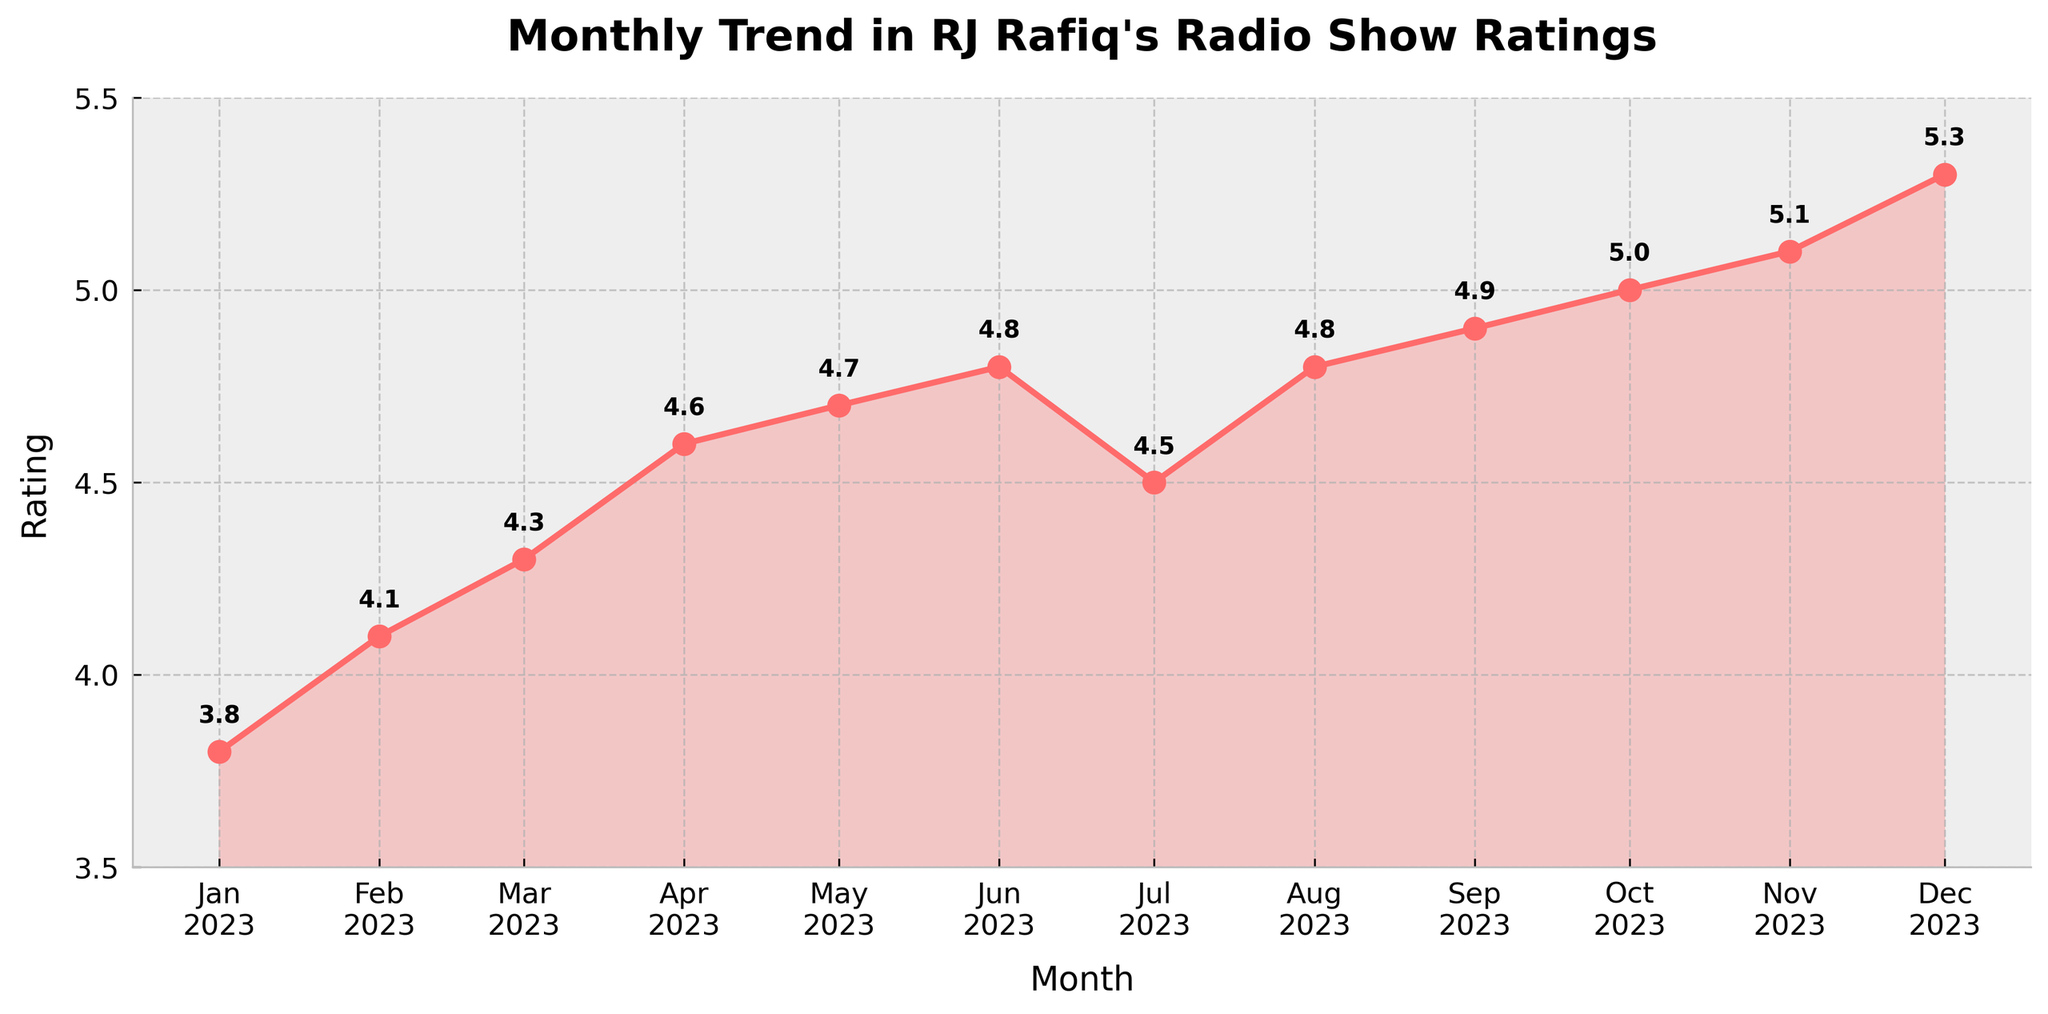What's the range of the ratings throughout the year? The range is calculated by subtracting the minimum rating from the maximum rating observed in the plot. The lowest rating is 3.8 (January) and the highest is 5.3 (December). Thus, the range is 5.3 - 3.8.
Answer: 1.5 Which months have the highest rating? From the plot, the highest rating observed is 5.3. This occurred in December 2023.
Answer: December 2023 How did the rating change from January to December 2023? To find the change, subtract the January rating from the December rating: 5.3 - 3.8. The plot shows an overall increase.
Answer: Increased by 1.5 During which months did the rating remain constant or show an increase compared to the previous month? By analyzing the plot, we need to find instances where the rating didn't drop compared to the previous month. All months except July show either constant or increased ratings.
Answer: All months except July Which month saw the biggest increase in ratings? From the plot data, the biggest increase is calculated by finding the month-to-month differences. The highest difference is between June (4.8) and July (4.5), which is a drop, so we should consider the increase from April (4.6) to May (4.7).
Answer: May 2023 During which months did the rating decrease compared to the previous month? To identify the months where the rating decreased, we observe the plot where the line drops. The rating decreased in July (4.5) compared to June (4.8).
Answer: July 2023 What is the average rating for the entire year? Sum all the ratings and divide by the number of months: (3.8 + 4.1 + 4.3 + 4.6 + 4.7 + 4.8 + 4.5 + 4.8 + 4.9 + 5.0 + 5.1 + 5.3) / 12. This results in an average.
Answer: 4.7 How much did the rating increase from the lowest point to the highest point observed in the plot? Identify the lowest point (3.8 in January) and the highest point (5.3 in December). The increase is calculated as 5.3 - 3.8.
Answer: 1.5 